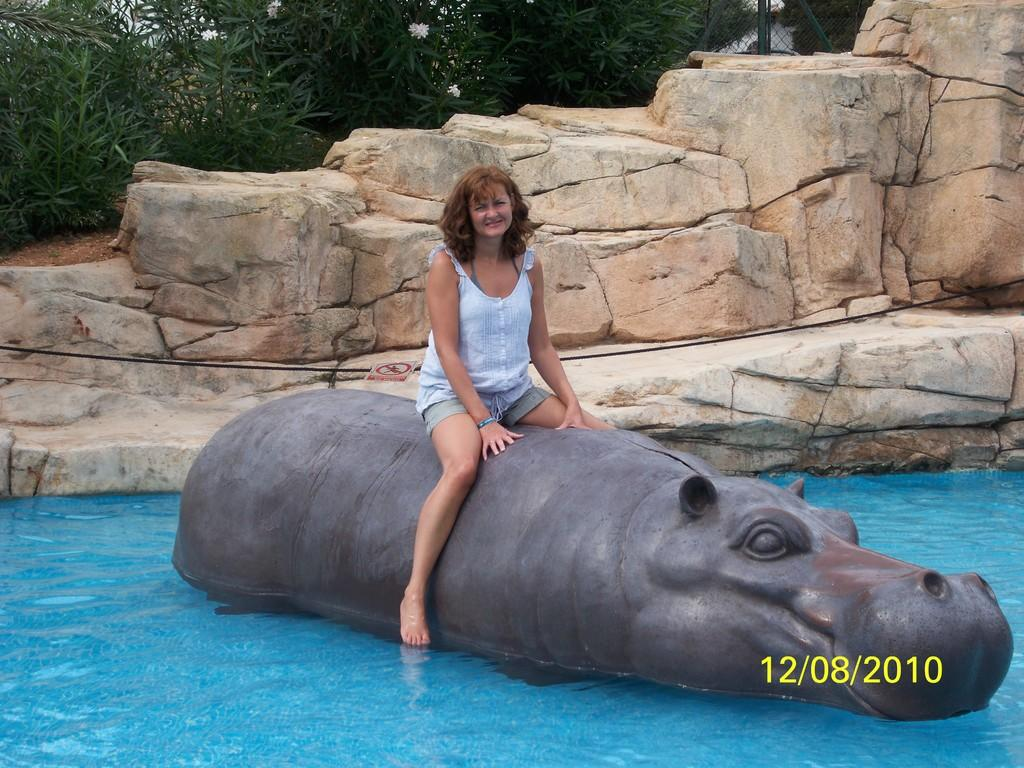What animal is present in the image? There is a hippo in the image. What is the woman doing in relation to the hippo? A woman is sitting on the hippo. What can be seen at the bottom of the image? There is water at the bottom of the image. What type of natural features are visible in the background? There are rocks and trees in the background of the image. What is the woman's opinion on toothpaste in the image? There is no information about toothpaste or the woman's opinion on it in the image. 